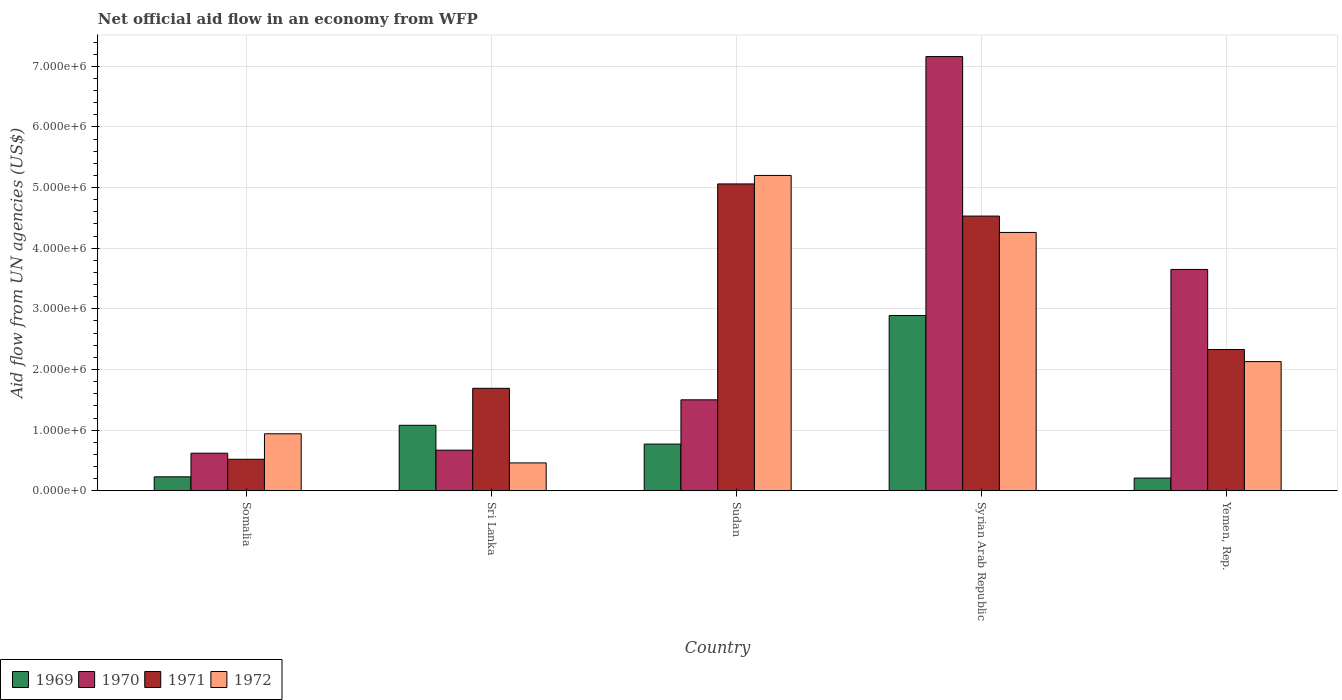How many different coloured bars are there?
Your response must be concise. 4. Are the number of bars on each tick of the X-axis equal?
Offer a terse response. Yes. How many bars are there on the 2nd tick from the left?
Your answer should be very brief. 4. What is the label of the 2nd group of bars from the left?
Keep it short and to the point. Sri Lanka. In how many cases, is the number of bars for a given country not equal to the number of legend labels?
Provide a succinct answer. 0. What is the net official aid flow in 1970 in Syrian Arab Republic?
Ensure brevity in your answer.  7.16e+06. Across all countries, what is the maximum net official aid flow in 1972?
Give a very brief answer. 5.20e+06. Across all countries, what is the minimum net official aid flow in 1969?
Your answer should be compact. 2.10e+05. In which country was the net official aid flow in 1972 maximum?
Provide a short and direct response. Sudan. In which country was the net official aid flow in 1971 minimum?
Ensure brevity in your answer.  Somalia. What is the total net official aid flow in 1972 in the graph?
Keep it short and to the point. 1.30e+07. What is the difference between the net official aid flow in 1971 in Sri Lanka and that in Yemen, Rep.?
Offer a terse response. -6.40e+05. What is the difference between the net official aid flow in 1969 in Somalia and the net official aid flow in 1970 in Syrian Arab Republic?
Your answer should be compact. -6.93e+06. What is the average net official aid flow in 1971 per country?
Offer a very short reply. 2.83e+06. What is the difference between the net official aid flow of/in 1970 and net official aid flow of/in 1971 in Somalia?
Your response must be concise. 1.00e+05. What is the ratio of the net official aid flow in 1971 in Syrian Arab Republic to that in Yemen, Rep.?
Make the answer very short. 1.94. What is the difference between the highest and the second highest net official aid flow in 1972?
Your answer should be compact. 3.07e+06. What is the difference between the highest and the lowest net official aid flow in 1969?
Provide a succinct answer. 2.68e+06. In how many countries, is the net official aid flow in 1969 greater than the average net official aid flow in 1969 taken over all countries?
Give a very brief answer. 2. Is the sum of the net official aid flow in 1969 in Sudan and Syrian Arab Republic greater than the maximum net official aid flow in 1971 across all countries?
Provide a short and direct response. No. What does the 4th bar from the left in Sudan represents?
Offer a very short reply. 1972. Are all the bars in the graph horizontal?
Give a very brief answer. No. How many countries are there in the graph?
Your answer should be very brief. 5. Are the values on the major ticks of Y-axis written in scientific E-notation?
Provide a short and direct response. Yes. Does the graph contain any zero values?
Your answer should be compact. No. Does the graph contain grids?
Offer a terse response. Yes. How are the legend labels stacked?
Keep it short and to the point. Horizontal. What is the title of the graph?
Your response must be concise. Net official aid flow in an economy from WFP. Does "1984" appear as one of the legend labels in the graph?
Your response must be concise. No. What is the label or title of the X-axis?
Provide a succinct answer. Country. What is the label or title of the Y-axis?
Your answer should be compact. Aid flow from UN agencies (US$). What is the Aid flow from UN agencies (US$) of 1970 in Somalia?
Your answer should be compact. 6.20e+05. What is the Aid flow from UN agencies (US$) of 1971 in Somalia?
Keep it short and to the point. 5.20e+05. What is the Aid flow from UN agencies (US$) in 1972 in Somalia?
Your answer should be very brief. 9.40e+05. What is the Aid flow from UN agencies (US$) in 1969 in Sri Lanka?
Offer a terse response. 1.08e+06. What is the Aid flow from UN agencies (US$) of 1970 in Sri Lanka?
Give a very brief answer. 6.70e+05. What is the Aid flow from UN agencies (US$) of 1971 in Sri Lanka?
Provide a succinct answer. 1.69e+06. What is the Aid flow from UN agencies (US$) in 1969 in Sudan?
Your response must be concise. 7.70e+05. What is the Aid flow from UN agencies (US$) of 1970 in Sudan?
Give a very brief answer. 1.50e+06. What is the Aid flow from UN agencies (US$) of 1971 in Sudan?
Provide a short and direct response. 5.06e+06. What is the Aid flow from UN agencies (US$) in 1972 in Sudan?
Your response must be concise. 5.20e+06. What is the Aid flow from UN agencies (US$) in 1969 in Syrian Arab Republic?
Ensure brevity in your answer.  2.89e+06. What is the Aid flow from UN agencies (US$) of 1970 in Syrian Arab Republic?
Give a very brief answer. 7.16e+06. What is the Aid flow from UN agencies (US$) of 1971 in Syrian Arab Republic?
Offer a terse response. 4.53e+06. What is the Aid flow from UN agencies (US$) in 1972 in Syrian Arab Republic?
Give a very brief answer. 4.26e+06. What is the Aid flow from UN agencies (US$) of 1970 in Yemen, Rep.?
Make the answer very short. 3.65e+06. What is the Aid flow from UN agencies (US$) in 1971 in Yemen, Rep.?
Your response must be concise. 2.33e+06. What is the Aid flow from UN agencies (US$) of 1972 in Yemen, Rep.?
Provide a succinct answer. 2.13e+06. Across all countries, what is the maximum Aid flow from UN agencies (US$) of 1969?
Offer a very short reply. 2.89e+06. Across all countries, what is the maximum Aid flow from UN agencies (US$) of 1970?
Offer a terse response. 7.16e+06. Across all countries, what is the maximum Aid flow from UN agencies (US$) of 1971?
Make the answer very short. 5.06e+06. Across all countries, what is the maximum Aid flow from UN agencies (US$) in 1972?
Keep it short and to the point. 5.20e+06. Across all countries, what is the minimum Aid flow from UN agencies (US$) of 1969?
Your answer should be compact. 2.10e+05. Across all countries, what is the minimum Aid flow from UN agencies (US$) in 1970?
Provide a short and direct response. 6.20e+05. Across all countries, what is the minimum Aid flow from UN agencies (US$) of 1971?
Your answer should be compact. 5.20e+05. What is the total Aid flow from UN agencies (US$) in 1969 in the graph?
Provide a short and direct response. 5.18e+06. What is the total Aid flow from UN agencies (US$) of 1970 in the graph?
Offer a very short reply. 1.36e+07. What is the total Aid flow from UN agencies (US$) in 1971 in the graph?
Keep it short and to the point. 1.41e+07. What is the total Aid flow from UN agencies (US$) in 1972 in the graph?
Make the answer very short. 1.30e+07. What is the difference between the Aid flow from UN agencies (US$) in 1969 in Somalia and that in Sri Lanka?
Offer a terse response. -8.50e+05. What is the difference between the Aid flow from UN agencies (US$) in 1970 in Somalia and that in Sri Lanka?
Offer a terse response. -5.00e+04. What is the difference between the Aid flow from UN agencies (US$) of 1971 in Somalia and that in Sri Lanka?
Provide a short and direct response. -1.17e+06. What is the difference between the Aid flow from UN agencies (US$) in 1969 in Somalia and that in Sudan?
Your response must be concise. -5.40e+05. What is the difference between the Aid flow from UN agencies (US$) in 1970 in Somalia and that in Sudan?
Your answer should be compact. -8.80e+05. What is the difference between the Aid flow from UN agencies (US$) of 1971 in Somalia and that in Sudan?
Offer a terse response. -4.54e+06. What is the difference between the Aid flow from UN agencies (US$) of 1972 in Somalia and that in Sudan?
Provide a succinct answer. -4.26e+06. What is the difference between the Aid flow from UN agencies (US$) of 1969 in Somalia and that in Syrian Arab Republic?
Your answer should be compact. -2.66e+06. What is the difference between the Aid flow from UN agencies (US$) in 1970 in Somalia and that in Syrian Arab Republic?
Offer a very short reply. -6.54e+06. What is the difference between the Aid flow from UN agencies (US$) of 1971 in Somalia and that in Syrian Arab Republic?
Offer a terse response. -4.01e+06. What is the difference between the Aid flow from UN agencies (US$) in 1972 in Somalia and that in Syrian Arab Republic?
Your answer should be compact. -3.32e+06. What is the difference between the Aid flow from UN agencies (US$) of 1969 in Somalia and that in Yemen, Rep.?
Keep it short and to the point. 2.00e+04. What is the difference between the Aid flow from UN agencies (US$) of 1970 in Somalia and that in Yemen, Rep.?
Offer a terse response. -3.03e+06. What is the difference between the Aid flow from UN agencies (US$) in 1971 in Somalia and that in Yemen, Rep.?
Give a very brief answer. -1.81e+06. What is the difference between the Aid flow from UN agencies (US$) in 1972 in Somalia and that in Yemen, Rep.?
Offer a very short reply. -1.19e+06. What is the difference between the Aid flow from UN agencies (US$) in 1969 in Sri Lanka and that in Sudan?
Your answer should be compact. 3.10e+05. What is the difference between the Aid flow from UN agencies (US$) in 1970 in Sri Lanka and that in Sudan?
Make the answer very short. -8.30e+05. What is the difference between the Aid flow from UN agencies (US$) in 1971 in Sri Lanka and that in Sudan?
Keep it short and to the point. -3.37e+06. What is the difference between the Aid flow from UN agencies (US$) in 1972 in Sri Lanka and that in Sudan?
Give a very brief answer. -4.74e+06. What is the difference between the Aid flow from UN agencies (US$) of 1969 in Sri Lanka and that in Syrian Arab Republic?
Offer a very short reply. -1.81e+06. What is the difference between the Aid flow from UN agencies (US$) of 1970 in Sri Lanka and that in Syrian Arab Republic?
Your answer should be very brief. -6.49e+06. What is the difference between the Aid flow from UN agencies (US$) in 1971 in Sri Lanka and that in Syrian Arab Republic?
Offer a terse response. -2.84e+06. What is the difference between the Aid flow from UN agencies (US$) in 1972 in Sri Lanka and that in Syrian Arab Republic?
Offer a terse response. -3.80e+06. What is the difference between the Aid flow from UN agencies (US$) in 1969 in Sri Lanka and that in Yemen, Rep.?
Your answer should be very brief. 8.70e+05. What is the difference between the Aid flow from UN agencies (US$) in 1970 in Sri Lanka and that in Yemen, Rep.?
Provide a succinct answer. -2.98e+06. What is the difference between the Aid flow from UN agencies (US$) of 1971 in Sri Lanka and that in Yemen, Rep.?
Provide a succinct answer. -6.40e+05. What is the difference between the Aid flow from UN agencies (US$) in 1972 in Sri Lanka and that in Yemen, Rep.?
Your answer should be compact. -1.67e+06. What is the difference between the Aid flow from UN agencies (US$) in 1969 in Sudan and that in Syrian Arab Republic?
Provide a short and direct response. -2.12e+06. What is the difference between the Aid flow from UN agencies (US$) in 1970 in Sudan and that in Syrian Arab Republic?
Offer a very short reply. -5.66e+06. What is the difference between the Aid flow from UN agencies (US$) in 1971 in Sudan and that in Syrian Arab Republic?
Your response must be concise. 5.30e+05. What is the difference between the Aid flow from UN agencies (US$) of 1972 in Sudan and that in Syrian Arab Republic?
Your answer should be compact. 9.40e+05. What is the difference between the Aid flow from UN agencies (US$) of 1969 in Sudan and that in Yemen, Rep.?
Ensure brevity in your answer.  5.60e+05. What is the difference between the Aid flow from UN agencies (US$) in 1970 in Sudan and that in Yemen, Rep.?
Offer a terse response. -2.15e+06. What is the difference between the Aid flow from UN agencies (US$) of 1971 in Sudan and that in Yemen, Rep.?
Provide a short and direct response. 2.73e+06. What is the difference between the Aid flow from UN agencies (US$) of 1972 in Sudan and that in Yemen, Rep.?
Offer a very short reply. 3.07e+06. What is the difference between the Aid flow from UN agencies (US$) in 1969 in Syrian Arab Republic and that in Yemen, Rep.?
Your response must be concise. 2.68e+06. What is the difference between the Aid flow from UN agencies (US$) of 1970 in Syrian Arab Republic and that in Yemen, Rep.?
Make the answer very short. 3.51e+06. What is the difference between the Aid flow from UN agencies (US$) of 1971 in Syrian Arab Republic and that in Yemen, Rep.?
Keep it short and to the point. 2.20e+06. What is the difference between the Aid flow from UN agencies (US$) in 1972 in Syrian Arab Republic and that in Yemen, Rep.?
Offer a terse response. 2.13e+06. What is the difference between the Aid flow from UN agencies (US$) of 1969 in Somalia and the Aid flow from UN agencies (US$) of 1970 in Sri Lanka?
Offer a very short reply. -4.40e+05. What is the difference between the Aid flow from UN agencies (US$) of 1969 in Somalia and the Aid flow from UN agencies (US$) of 1971 in Sri Lanka?
Offer a terse response. -1.46e+06. What is the difference between the Aid flow from UN agencies (US$) in 1970 in Somalia and the Aid flow from UN agencies (US$) in 1971 in Sri Lanka?
Keep it short and to the point. -1.07e+06. What is the difference between the Aid flow from UN agencies (US$) in 1970 in Somalia and the Aid flow from UN agencies (US$) in 1972 in Sri Lanka?
Make the answer very short. 1.60e+05. What is the difference between the Aid flow from UN agencies (US$) of 1971 in Somalia and the Aid flow from UN agencies (US$) of 1972 in Sri Lanka?
Provide a succinct answer. 6.00e+04. What is the difference between the Aid flow from UN agencies (US$) in 1969 in Somalia and the Aid flow from UN agencies (US$) in 1970 in Sudan?
Your answer should be compact. -1.27e+06. What is the difference between the Aid flow from UN agencies (US$) of 1969 in Somalia and the Aid flow from UN agencies (US$) of 1971 in Sudan?
Ensure brevity in your answer.  -4.83e+06. What is the difference between the Aid flow from UN agencies (US$) of 1969 in Somalia and the Aid flow from UN agencies (US$) of 1972 in Sudan?
Your answer should be compact. -4.97e+06. What is the difference between the Aid flow from UN agencies (US$) in 1970 in Somalia and the Aid flow from UN agencies (US$) in 1971 in Sudan?
Provide a short and direct response. -4.44e+06. What is the difference between the Aid flow from UN agencies (US$) of 1970 in Somalia and the Aid flow from UN agencies (US$) of 1972 in Sudan?
Offer a very short reply. -4.58e+06. What is the difference between the Aid flow from UN agencies (US$) in 1971 in Somalia and the Aid flow from UN agencies (US$) in 1972 in Sudan?
Offer a very short reply. -4.68e+06. What is the difference between the Aid flow from UN agencies (US$) of 1969 in Somalia and the Aid flow from UN agencies (US$) of 1970 in Syrian Arab Republic?
Make the answer very short. -6.93e+06. What is the difference between the Aid flow from UN agencies (US$) in 1969 in Somalia and the Aid flow from UN agencies (US$) in 1971 in Syrian Arab Republic?
Keep it short and to the point. -4.30e+06. What is the difference between the Aid flow from UN agencies (US$) of 1969 in Somalia and the Aid flow from UN agencies (US$) of 1972 in Syrian Arab Republic?
Ensure brevity in your answer.  -4.03e+06. What is the difference between the Aid flow from UN agencies (US$) of 1970 in Somalia and the Aid flow from UN agencies (US$) of 1971 in Syrian Arab Republic?
Give a very brief answer. -3.91e+06. What is the difference between the Aid flow from UN agencies (US$) in 1970 in Somalia and the Aid flow from UN agencies (US$) in 1972 in Syrian Arab Republic?
Keep it short and to the point. -3.64e+06. What is the difference between the Aid flow from UN agencies (US$) in 1971 in Somalia and the Aid flow from UN agencies (US$) in 1972 in Syrian Arab Republic?
Give a very brief answer. -3.74e+06. What is the difference between the Aid flow from UN agencies (US$) in 1969 in Somalia and the Aid flow from UN agencies (US$) in 1970 in Yemen, Rep.?
Your answer should be very brief. -3.42e+06. What is the difference between the Aid flow from UN agencies (US$) in 1969 in Somalia and the Aid flow from UN agencies (US$) in 1971 in Yemen, Rep.?
Make the answer very short. -2.10e+06. What is the difference between the Aid flow from UN agencies (US$) of 1969 in Somalia and the Aid flow from UN agencies (US$) of 1972 in Yemen, Rep.?
Make the answer very short. -1.90e+06. What is the difference between the Aid flow from UN agencies (US$) in 1970 in Somalia and the Aid flow from UN agencies (US$) in 1971 in Yemen, Rep.?
Make the answer very short. -1.71e+06. What is the difference between the Aid flow from UN agencies (US$) of 1970 in Somalia and the Aid flow from UN agencies (US$) of 1972 in Yemen, Rep.?
Provide a succinct answer. -1.51e+06. What is the difference between the Aid flow from UN agencies (US$) of 1971 in Somalia and the Aid flow from UN agencies (US$) of 1972 in Yemen, Rep.?
Keep it short and to the point. -1.61e+06. What is the difference between the Aid flow from UN agencies (US$) in 1969 in Sri Lanka and the Aid flow from UN agencies (US$) in 1970 in Sudan?
Your answer should be compact. -4.20e+05. What is the difference between the Aid flow from UN agencies (US$) in 1969 in Sri Lanka and the Aid flow from UN agencies (US$) in 1971 in Sudan?
Offer a terse response. -3.98e+06. What is the difference between the Aid flow from UN agencies (US$) in 1969 in Sri Lanka and the Aid flow from UN agencies (US$) in 1972 in Sudan?
Make the answer very short. -4.12e+06. What is the difference between the Aid flow from UN agencies (US$) of 1970 in Sri Lanka and the Aid flow from UN agencies (US$) of 1971 in Sudan?
Ensure brevity in your answer.  -4.39e+06. What is the difference between the Aid flow from UN agencies (US$) in 1970 in Sri Lanka and the Aid flow from UN agencies (US$) in 1972 in Sudan?
Keep it short and to the point. -4.53e+06. What is the difference between the Aid flow from UN agencies (US$) of 1971 in Sri Lanka and the Aid flow from UN agencies (US$) of 1972 in Sudan?
Keep it short and to the point. -3.51e+06. What is the difference between the Aid flow from UN agencies (US$) in 1969 in Sri Lanka and the Aid flow from UN agencies (US$) in 1970 in Syrian Arab Republic?
Keep it short and to the point. -6.08e+06. What is the difference between the Aid flow from UN agencies (US$) in 1969 in Sri Lanka and the Aid flow from UN agencies (US$) in 1971 in Syrian Arab Republic?
Your answer should be compact. -3.45e+06. What is the difference between the Aid flow from UN agencies (US$) in 1969 in Sri Lanka and the Aid flow from UN agencies (US$) in 1972 in Syrian Arab Republic?
Make the answer very short. -3.18e+06. What is the difference between the Aid flow from UN agencies (US$) in 1970 in Sri Lanka and the Aid flow from UN agencies (US$) in 1971 in Syrian Arab Republic?
Your answer should be compact. -3.86e+06. What is the difference between the Aid flow from UN agencies (US$) in 1970 in Sri Lanka and the Aid flow from UN agencies (US$) in 1972 in Syrian Arab Republic?
Your answer should be compact. -3.59e+06. What is the difference between the Aid flow from UN agencies (US$) in 1971 in Sri Lanka and the Aid flow from UN agencies (US$) in 1972 in Syrian Arab Republic?
Your answer should be very brief. -2.57e+06. What is the difference between the Aid flow from UN agencies (US$) in 1969 in Sri Lanka and the Aid flow from UN agencies (US$) in 1970 in Yemen, Rep.?
Provide a short and direct response. -2.57e+06. What is the difference between the Aid flow from UN agencies (US$) of 1969 in Sri Lanka and the Aid flow from UN agencies (US$) of 1971 in Yemen, Rep.?
Give a very brief answer. -1.25e+06. What is the difference between the Aid flow from UN agencies (US$) in 1969 in Sri Lanka and the Aid flow from UN agencies (US$) in 1972 in Yemen, Rep.?
Your answer should be very brief. -1.05e+06. What is the difference between the Aid flow from UN agencies (US$) in 1970 in Sri Lanka and the Aid flow from UN agencies (US$) in 1971 in Yemen, Rep.?
Offer a very short reply. -1.66e+06. What is the difference between the Aid flow from UN agencies (US$) of 1970 in Sri Lanka and the Aid flow from UN agencies (US$) of 1972 in Yemen, Rep.?
Give a very brief answer. -1.46e+06. What is the difference between the Aid flow from UN agencies (US$) of 1971 in Sri Lanka and the Aid flow from UN agencies (US$) of 1972 in Yemen, Rep.?
Your answer should be compact. -4.40e+05. What is the difference between the Aid flow from UN agencies (US$) in 1969 in Sudan and the Aid flow from UN agencies (US$) in 1970 in Syrian Arab Republic?
Keep it short and to the point. -6.39e+06. What is the difference between the Aid flow from UN agencies (US$) in 1969 in Sudan and the Aid flow from UN agencies (US$) in 1971 in Syrian Arab Republic?
Offer a very short reply. -3.76e+06. What is the difference between the Aid flow from UN agencies (US$) of 1969 in Sudan and the Aid flow from UN agencies (US$) of 1972 in Syrian Arab Republic?
Offer a very short reply. -3.49e+06. What is the difference between the Aid flow from UN agencies (US$) in 1970 in Sudan and the Aid flow from UN agencies (US$) in 1971 in Syrian Arab Republic?
Your answer should be very brief. -3.03e+06. What is the difference between the Aid flow from UN agencies (US$) of 1970 in Sudan and the Aid flow from UN agencies (US$) of 1972 in Syrian Arab Republic?
Make the answer very short. -2.76e+06. What is the difference between the Aid flow from UN agencies (US$) of 1971 in Sudan and the Aid flow from UN agencies (US$) of 1972 in Syrian Arab Republic?
Make the answer very short. 8.00e+05. What is the difference between the Aid flow from UN agencies (US$) of 1969 in Sudan and the Aid flow from UN agencies (US$) of 1970 in Yemen, Rep.?
Offer a very short reply. -2.88e+06. What is the difference between the Aid flow from UN agencies (US$) in 1969 in Sudan and the Aid flow from UN agencies (US$) in 1971 in Yemen, Rep.?
Your answer should be compact. -1.56e+06. What is the difference between the Aid flow from UN agencies (US$) of 1969 in Sudan and the Aid flow from UN agencies (US$) of 1972 in Yemen, Rep.?
Provide a succinct answer. -1.36e+06. What is the difference between the Aid flow from UN agencies (US$) in 1970 in Sudan and the Aid flow from UN agencies (US$) in 1971 in Yemen, Rep.?
Offer a terse response. -8.30e+05. What is the difference between the Aid flow from UN agencies (US$) of 1970 in Sudan and the Aid flow from UN agencies (US$) of 1972 in Yemen, Rep.?
Your response must be concise. -6.30e+05. What is the difference between the Aid flow from UN agencies (US$) in 1971 in Sudan and the Aid flow from UN agencies (US$) in 1972 in Yemen, Rep.?
Ensure brevity in your answer.  2.93e+06. What is the difference between the Aid flow from UN agencies (US$) in 1969 in Syrian Arab Republic and the Aid flow from UN agencies (US$) in 1970 in Yemen, Rep.?
Offer a terse response. -7.60e+05. What is the difference between the Aid flow from UN agencies (US$) in 1969 in Syrian Arab Republic and the Aid flow from UN agencies (US$) in 1971 in Yemen, Rep.?
Your response must be concise. 5.60e+05. What is the difference between the Aid flow from UN agencies (US$) in 1969 in Syrian Arab Republic and the Aid flow from UN agencies (US$) in 1972 in Yemen, Rep.?
Keep it short and to the point. 7.60e+05. What is the difference between the Aid flow from UN agencies (US$) of 1970 in Syrian Arab Republic and the Aid flow from UN agencies (US$) of 1971 in Yemen, Rep.?
Keep it short and to the point. 4.83e+06. What is the difference between the Aid flow from UN agencies (US$) in 1970 in Syrian Arab Republic and the Aid flow from UN agencies (US$) in 1972 in Yemen, Rep.?
Your answer should be very brief. 5.03e+06. What is the difference between the Aid flow from UN agencies (US$) of 1971 in Syrian Arab Republic and the Aid flow from UN agencies (US$) of 1972 in Yemen, Rep.?
Your answer should be compact. 2.40e+06. What is the average Aid flow from UN agencies (US$) of 1969 per country?
Your response must be concise. 1.04e+06. What is the average Aid flow from UN agencies (US$) in 1970 per country?
Provide a succinct answer. 2.72e+06. What is the average Aid flow from UN agencies (US$) in 1971 per country?
Your answer should be compact. 2.83e+06. What is the average Aid flow from UN agencies (US$) of 1972 per country?
Your response must be concise. 2.60e+06. What is the difference between the Aid flow from UN agencies (US$) of 1969 and Aid flow from UN agencies (US$) of 1970 in Somalia?
Make the answer very short. -3.90e+05. What is the difference between the Aid flow from UN agencies (US$) in 1969 and Aid flow from UN agencies (US$) in 1972 in Somalia?
Provide a succinct answer. -7.10e+05. What is the difference between the Aid flow from UN agencies (US$) of 1970 and Aid flow from UN agencies (US$) of 1972 in Somalia?
Give a very brief answer. -3.20e+05. What is the difference between the Aid flow from UN agencies (US$) in 1971 and Aid flow from UN agencies (US$) in 1972 in Somalia?
Give a very brief answer. -4.20e+05. What is the difference between the Aid flow from UN agencies (US$) in 1969 and Aid flow from UN agencies (US$) in 1970 in Sri Lanka?
Provide a short and direct response. 4.10e+05. What is the difference between the Aid flow from UN agencies (US$) of 1969 and Aid flow from UN agencies (US$) of 1971 in Sri Lanka?
Provide a short and direct response. -6.10e+05. What is the difference between the Aid flow from UN agencies (US$) in 1969 and Aid flow from UN agencies (US$) in 1972 in Sri Lanka?
Provide a short and direct response. 6.20e+05. What is the difference between the Aid flow from UN agencies (US$) in 1970 and Aid flow from UN agencies (US$) in 1971 in Sri Lanka?
Offer a terse response. -1.02e+06. What is the difference between the Aid flow from UN agencies (US$) of 1970 and Aid flow from UN agencies (US$) of 1972 in Sri Lanka?
Make the answer very short. 2.10e+05. What is the difference between the Aid flow from UN agencies (US$) in 1971 and Aid flow from UN agencies (US$) in 1972 in Sri Lanka?
Ensure brevity in your answer.  1.23e+06. What is the difference between the Aid flow from UN agencies (US$) of 1969 and Aid flow from UN agencies (US$) of 1970 in Sudan?
Make the answer very short. -7.30e+05. What is the difference between the Aid flow from UN agencies (US$) of 1969 and Aid flow from UN agencies (US$) of 1971 in Sudan?
Your response must be concise. -4.29e+06. What is the difference between the Aid flow from UN agencies (US$) of 1969 and Aid flow from UN agencies (US$) of 1972 in Sudan?
Your answer should be compact. -4.43e+06. What is the difference between the Aid flow from UN agencies (US$) of 1970 and Aid flow from UN agencies (US$) of 1971 in Sudan?
Offer a very short reply. -3.56e+06. What is the difference between the Aid flow from UN agencies (US$) in 1970 and Aid flow from UN agencies (US$) in 1972 in Sudan?
Your answer should be compact. -3.70e+06. What is the difference between the Aid flow from UN agencies (US$) in 1971 and Aid flow from UN agencies (US$) in 1972 in Sudan?
Make the answer very short. -1.40e+05. What is the difference between the Aid flow from UN agencies (US$) of 1969 and Aid flow from UN agencies (US$) of 1970 in Syrian Arab Republic?
Ensure brevity in your answer.  -4.27e+06. What is the difference between the Aid flow from UN agencies (US$) in 1969 and Aid flow from UN agencies (US$) in 1971 in Syrian Arab Republic?
Offer a very short reply. -1.64e+06. What is the difference between the Aid flow from UN agencies (US$) of 1969 and Aid flow from UN agencies (US$) of 1972 in Syrian Arab Republic?
Offer a terse response. -1.37e+06. What is the difference between the Aid flow from UN agencies (US$) in 1970 and Aid flow from UN agencies (US$) in 1971 in Syrian Arab Republic?
Keep it short and to the point. 2.63e+06. What is the difference between the Aid flow from UN agencies (US$) in 1970 and Aid flow from UN agencies (US$) in 1972 in Syrian Arab Republic?
Offer a very short reply. 2.90e+06. What is the difference between the Aid flow from UN agencies (US$) of 1971 and Aid flow from UN agencies (US$) of 1972 in Syrian Arab Republic?
Your answer should be compact. 2.70e+05. What is the difference between the Aid flow from UN agencies (US$) in 1969 and Aid flow from UN agencies (US$) in 1970 in Yemen, Rep.?
Your answer should be compact. -3.44e+06. What is the difference between the Aid flow from UN agencies (US$) of 1969 and Aid flow from UN agencies (US$) of 1971 in Yemen, Rep.?
Offer a terse response. -2.12e+06. What is the difference between the Aid flow from UN agencies (US$) of 1969 and Aid flow from UN agencies (US$) of 1972 in Yemen, Rep.?
Your response must be concise. -1.92e+06. What is the difference between the Aid flow from UN agencies (US$) of 1970 and Aid flow from UN agencies (US$) of 1971 in Yemen, Rep.?
Provide a succinct answer. 1.32e+06. What is the difference between the Aid flow from UN agencies (US$) of 1970 and Aid flow from UN agencies (US$) of 1972 in Yemen, Rep.?
Keep it short and to the point. 1.52e+06. What is the ratio of the Aid flow from UN agencies (US$) of 1969 in Somalia to that in Sri Lanka?
Offer a terse response. 0.21. What is the ratio of the Aid flow from UN agencies (US$) in 1970 in Somalia to that in Sri Lanka?
Your answer should be very brief. 0.93. What is the ratio of the Aid flow from UN agencies (US$) of 1971 in Somalia to that in Sri Lanka?
Offer a very short reply. 0.31. What is the ratio of the Aid flow from UN agencies (US$) in 1972 in Somalia to that in Sri Lanka?
Ensure brevity in your answer.  2.04. What is the ratio of the Aid flow from UN agencies (US$) of 1969 in Somalia to that in Sudan?
Ensure brevity in your answer.  0.3. What is the ratio of the Aid flow from UN agencies (US$) of 1970 in Somalia to that in Sudan?
Make the answer very short. 0.41. What is the ratio of the Aid flow from UN agencies (US$) in 1971 in Somalia to that in Sudan?
Offer a very short reply. 0.1. What is the ratio of the Aid flow from UN agencies (US$) of 1972 in Somalia to that in Sudan?
Give a very brief answer. 0.18. What is the ratio of the Aid flow from UN agencies (US$) of 1969 in Somalia to that in Syrian Arab Republic?
Make the answer very short. 0.08. What is the ratio of the Aid flow from UN agencies (US$) of 1970 in Somalia to that in Syrian Arab Republic?
Give a very brief answer. 0.09. What is the ratio of the Aid flow from UN agencies (US$) of 1971 in Somalia to that in Syrian Arab Republic?
Make the answer very short. 0.11. What is the ratio of the Aid flow from UN agencies (US$) in 1972 in Somalia to that in Syrian Arab Republic?
Provide a succinct answer. 0.22. What is the ratio of the Aid flow from UN agencies (US$) of 1969 in Somalia to that in Yemen, Rep.?
Ensure brevity in your answer.  1.1. What is the ratio of the Aid flow from UN agencies (US$) of 1970 in Somalia to that in Yemen, Rep.?
Offer a terse response. 0.17. What is the ratio of the Aid flow from UN agencies (US$) in 1971 in Somalia to that in Yemen, Rep.?
Offer a very short reply. 0.22. What is the ratio of the Aid flow from UN agencies (US$) in 1972 in Somalia to that in Yemen, Rep.?
Make the answer very short. 0.44. What is the ratio of the Aid flow from UN agencies (US$) of 1969 in Sri Lanka to that in Sudan?
Provide a short and direct response. 1.4. What is the ratio of the Aid flow from UN agencies (US$) in 1970 in Sri Lanka to that in Sudan?
Make the answer very short. 0.45. What is the ratio of the Aid flow from UN agencies (US$) in 1971 in Sri Lanka to that in Sudan?
Provide a succinct answer. 0.33. What is the ratio of the Aid flow from UN agencies (US$) of 1972 in Sri Lanka to that in Sudan?
Give a very brief answer. 0.09. What is the ratio of the Aid flow from UN agencies (US$) in 1969 in Sri Lanka to that in Syrian Arab Republic?
Your answer should be very brief. 0.37. What is the ratio of the Aid flow from UN agencies (US$) of 1970 in Sri Lanka to that in Syrian Arab Republic?
Your answer should be compact. 0.09. What is the ratio of the Aid flow from UN agencies (US$) of 1971 in Sri Lanka to that in Syrian Arab Republic?
Offer a terse response. 0.37. What is the ratio of the Aid flow from UN agencies (US$) of 1972 in Sri Lanka to that in Syrian Arab Republic?
Your response must be concise. 0.11. What is the ratio of the Aid flow from UN agencies (US$) of 1969 in Sri Lanka to that in Yemen, Rep.?
Provide a short and direct response. 5.14. What is the ratio of the Aid flow from UN agencies (US$) in 1970 in Sri Lanka to that in Yemen, Rep.?
Ensure brevity in your answer.  0.18. What is the ratio of the Aid flow from UN agencies (US$) in 1971 in Sri Lanka to that in Yemen, Rep.?
Offer a terse response. 0.73. What is the ratio of the Aid flow from UN agencies (US$) in 1972 in Sri Lanka to that in Yemen, Rep.?
Provide a short and direct response. 0.22. What is the ratio of the Aid flow from UN agencies (US$) of 1969 in Sudan to that in Syrian Arab Republic?
Provide a succinct answer. 0.27. What is the ratio of the Aid flow from UN agencies (US$) in 1970 in Sudan to that in Syrian Arab Republic?
Your answer should be very brief. 0.21. What is the ratio of the Aid flow from UN agencies (US$) of 1971 in Sudan to that in Syrian Arab Republic?
Your answer should be very brief. 1.12. What is the ratio of the Aid flow from UN agencies (US$) in 1972 in Sudan to that in Syrian Arab Republic?
Keep it short and to the point. 1.22. What is the ratio of the Aid flow from UN agencies (US$) in 1969 in Sudan to that in Yemen, Rep.?
Provide a succinct answer. 3.67. What is the ratio of the Aid flow from UN agencies (US$) in 1970 in Sudan to that in Yemen, Rep.?
Your answer should be compact. 0.41. What is the ratio of the Aid flow from UN agencies (US$) of 1971 in Sudan to that in Yemen, Rep.?
Ensure brevity in your answer.  2.17. What is the ratio of the Aid flow from UN agencies (US$) in 1972 in Sudan to that in Yemen, Rep.?
Provide a succinct answer. 2.44. What is the ratio of the Aid flow from UN agencies (US$) of 1969 in Syrian Arab Republic to that in Yemen, Rep.?
Give a very brief answer. 13.76. What is the ratio of the Aid flow from UN agencies (US$) in 1970 in Syrian Arab Republic to that in Yemen, Rep.?
Give a very brief answer. 1.96. What is the ratio of the Aid flow from UN agencies (US$) in 1971 in Syrian Arab Republic to that in Yemen, Rep.?
Your response must be concise. 1.94. What is the ratio of the Aid flow from UN agencies (US$) in 1972 in Syrian Arab Republic to that in Yemen, Rep.?
Give a very brief answer. 2. What is the difference between the highest and the second highest Aid flow from UN agencies (US$) of 1969?
Your response must be concise. 1.81e+06. What is the difference between the highest and the second highest Aid flow from UN agencies (US$) of 1970?
Your response must be concise. 3.51e+06. What is the difference between the highest and the second highest Aid flow from UN agencies (US$) of 1971?
Your response must be concise. 5.30e+05. What is the difference between the highest and the second highest Aid flow from UN agencies (US$) in 1972?
Provide a succinct answer. 9.40e+05. What is the difference between the highest and the lowest Aid flow from UN agencies (US$) in 1969?
Offer a very short reply. 2.68e+06. What is the difference between the highest and the lowest Aid flow from UN agencies (US$) of 1970?
Your answer should be very brief. 6.54e+06. What is the difference between the highest and the lowest Aid flow from UN agencies (US$) in 1971?
Provide a succinct answer. 4.54e+06. What is the difference between the highest and the lowest Aid flow from UN agencies (US$) of 1972?
Your answer should be very brief. 4.74e+06. 